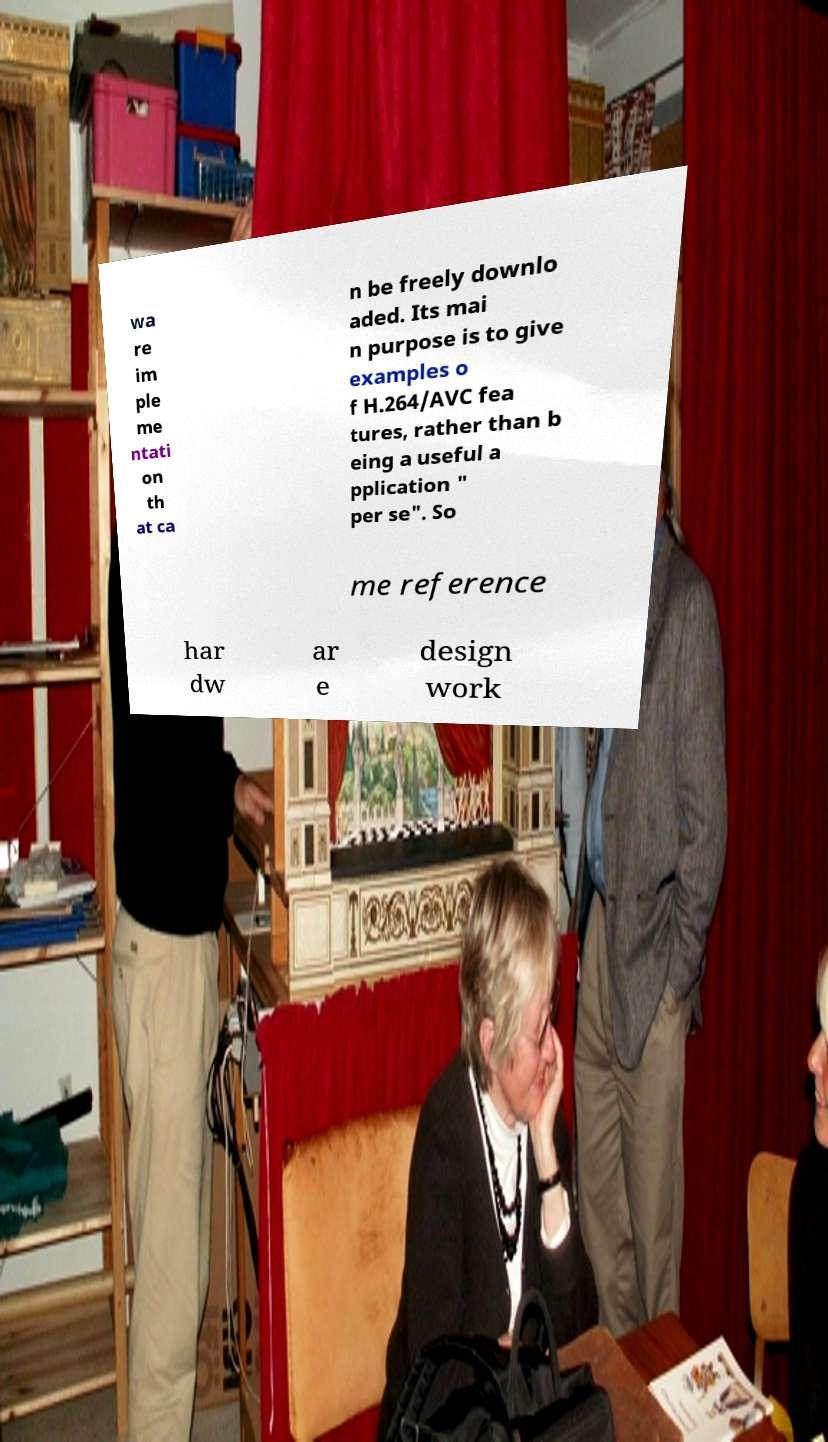Can you accurately transcribe the text from the provided image for me? wa re im ple me ntati on th at ca n be freely downlo aded. Its mai n purpose is to give examples o f H.264/AVC fea tures, rather than b eing a useful a pplication " per se". So me reference har dw ar e design work 